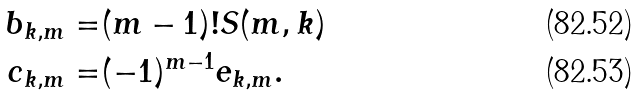<formula> <loc_0><loc_0><loc_500><loc_500>b _ { k , m } = & ( m - 1 ) ! S ( m , k ) \\ c _ { k , m } = & ( - 1 ) ^ { m - 1 } e _ { k , m } .</formula> 